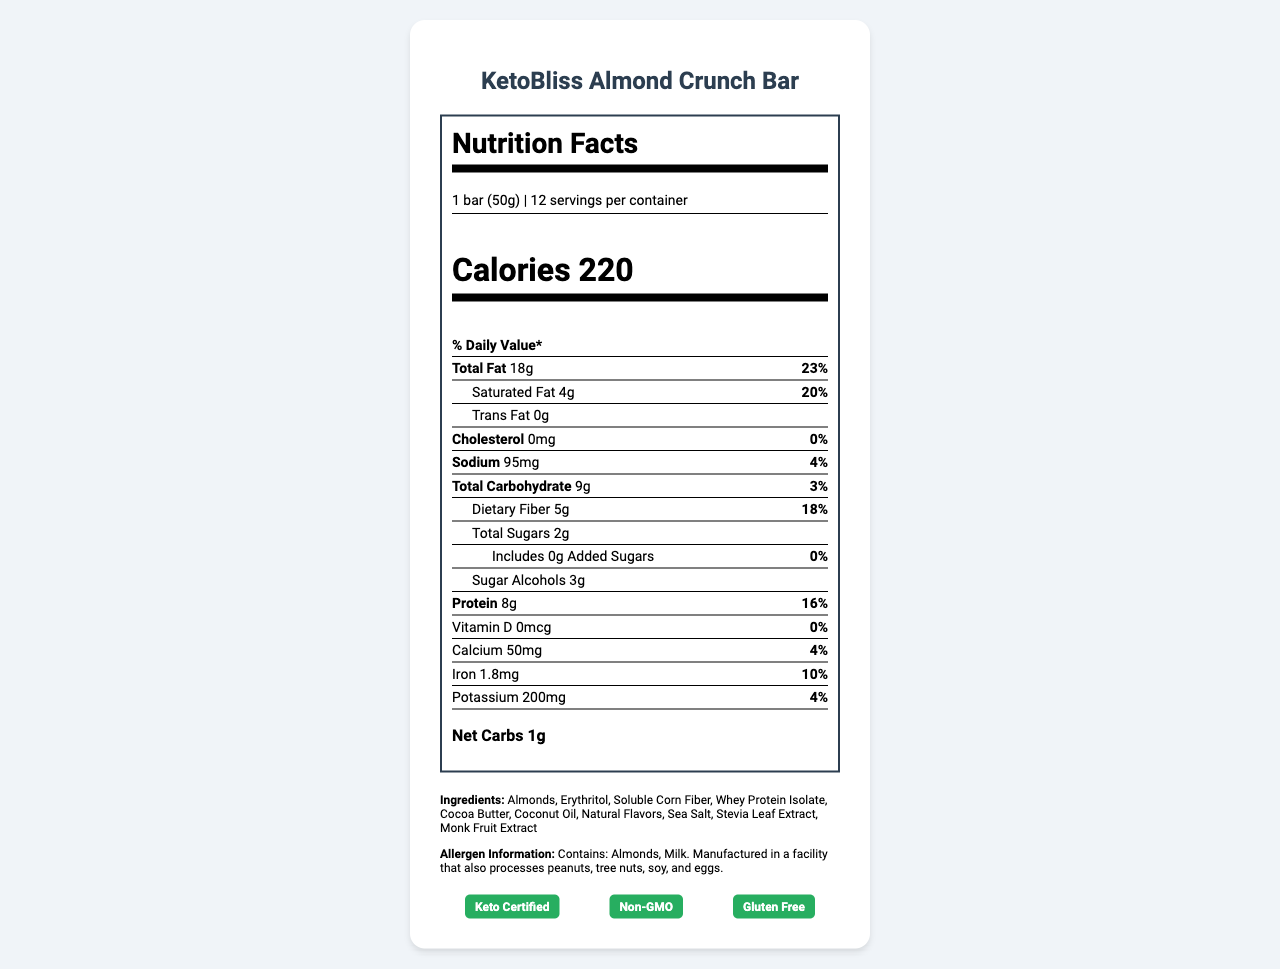what is the serving size of the KetoBliss Almond Crunch Bar? The serving size is listed at the top part of the nutrition label.
Answer: 1 bar (50g) how many calories are in one serving of the KetoBliss Almond Crunch Bar? The calories per serving are clearly stated under the "Calories" section.
Answer: 220 calories what is the total fat content per serving? The total fat content is specified in the nutrient rows under "Total Fat."
Answer: 18g how many grams of dietary fiber are in each bar? The dietary fiber content is listed under the "Dietary Fiber" section, indented under "Total Carbohydrate."
Answer: 5g what is the net carb count for the KetoBliss Almond Crunch Bar? The net carbs are given as "Net Carbs 1g" towards the bottom of the nutrition facts.
Answer: 1g which minerals are mentioned in the nutrition label? A. Calcium, Iron, Magnesium B. Calcium, Iron, Potassium C. Calcium, Zinc, Sodium The minerals listed under the "Nutrient Row" section are calcium, iron, and potassium.
Answer: B. Calcium, Iron, Potassium how many grams of added sugars are there in one bar? A. 0g B. 2g C. 5g D. 8g The amount of added sugars is listed as "Includes 0g Added Sugars."
Answer: A. 0g is the product keto certified? The label indicates that it is "Keto Certified" in the certifications section.
Answer: Yes is there any cholesterol in the KetoBliss Almond Crunch Bar? The cholesterol amount is listed as "0mg" with a daily value of "0%" in the nutrient row for cholesterol.
Answer: No describe the main idea of the document This summary captures the core content and purpose of the nutrition label, providing an overview of its various sections.
Answer: The document provides the nutrition facts for the KetoBliss Almond Crunch Bar, including serving size, calories, macronutrient content (fats, carbs, proteins), key vitamins and minerals, ingredients, allergen information, and certifications such as keto certified, non-GMO, and gluten-free, aimed at health-conscious consumers following ketogenic or low-carb diets. how much sodium is in one serving? The sodium content is listed as "95mg" under the "Nutrient Row" for sodium.
Answer: 95mg which one of the following labels is not on the bar? A. Keto Certified B. Organic C. Non-GMO D. Gluten Free The label does not mention "Organic," but it does include "Keto Certified," "Non-GMO," and "Gluten Free."
Answer: B. Organic is this bar suitable for people with peanut allergies? Although the label mentions that it contains almonds and milk and is manufactured in a facility that processes peanuts, it does not definitively indicate whether it is safe for peanut allergy sufferers.
Answer: Not enough information why might this product be considered ideal for a ketogenic diet? The nutritional breakdown including 18g of fat, 8g of protein, and 1g of net carbs per serving is aligned with keto dietary requirements.
Answer: It has a high fat content, moderate protein, and very low net carbs. what are the first three ingredients listed? The ingredients are listed in descending order by weight, so the first three ingredients are Almonds, Erythritol, and Soluble Corn Fiber.
Answer: Almonds, Erythritol, Soluble Corn Fiber 